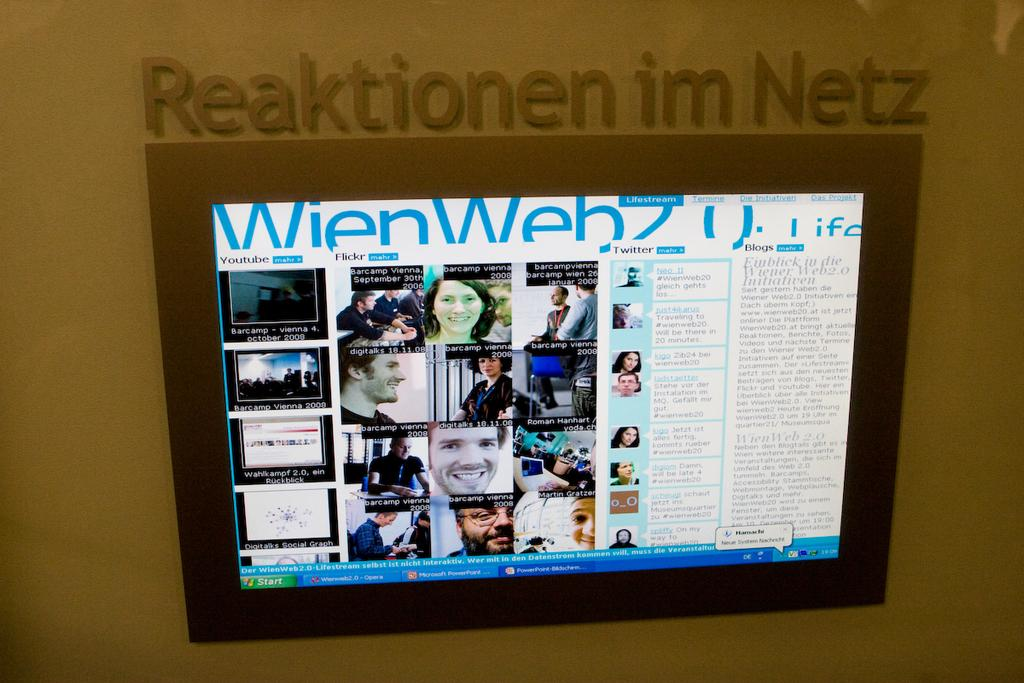Provide a one-sentence caption for the provided image. A screen is mounted on a wall under the words "Reaktionen im Netz.". 